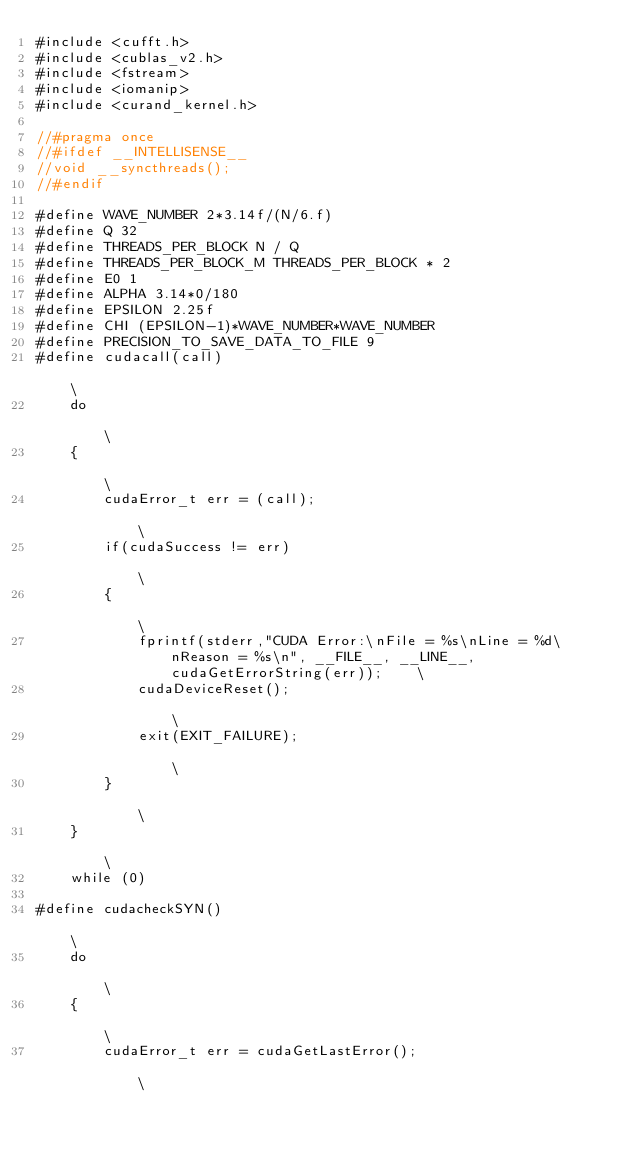Convert code to text. <code><loc_0><loc_0><loc_500><loc_500><_Cuda_>#include <cufft.h>
#include <cublas_v2.h>
#include <fstream>
#include <iomanip>
#include <curand_kernel.h>

//#pragma once
//#ifdef __INTELLISENSE__
//void __syncthreads();
//#endif

#define WAVE_NUMBER 2*3.14f/(N/6.f)
#define Q 32
#define THREADS_PER_BLOCK N / Q
#define THREADS_PER_BLOCK_M THREADS_PER_BLOCK * 2
#define E0 1
#define ALPHA 3.14*0/180
#define EPSILON 2.25f
#define CHI (EPSILON-1)*WAVE_NUMBER*WAVE_NUMBER
#define PRECISION_TO_SAVE_DATA_TO_FILE 9
#define cudacall(call)                                                                                                          \
    do                                                                                                                          \
    {                                                                                                                           \
        cudaError_t err = (call);                                                                                               \
        if(cudaSuccess != err)                                                                                                  \
        {                                                                                                                       \
            fprintf(stderr,"CUDA Error:\nFile = %s\nLine = %d\nReason = %s\n", __FILE__, __LINE__, cudaGetErrorString(err));    \
            cudaDeviceReset();                                                                                                  \
            exit(EXIT_FAILURE);                                                                                                 \
        }                                                                                                                       \
    }                                                                                                                           \
    while (0)

#define cudacheckSYN()                                                                                                          \
    do                                                                                                                          \
    {                                                                                                                           \
        cudaError_t err = cudaGetLastError();                                                                                   \</code> 